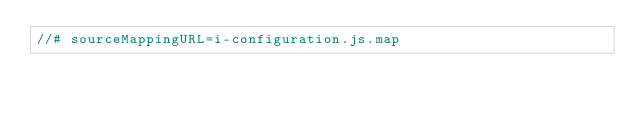Convert code to text. <code><loc_0><loc_0><loc_500><loc_500><_JavaScript_>//# sourceMappingURL=i-configuration.js.map</code> 